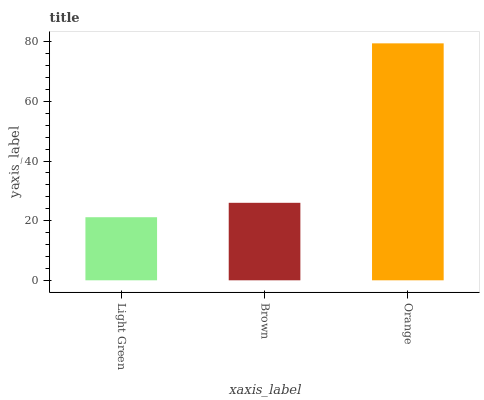Is Light Green the minimum?
Answer yes or no. Yes. Is Orange the maximum?
Answer yes or no. Yes. Is Brown the minimum?
Answer yes or no. No. Is Brown the maximum?
Answer yes or no. No. Is Brown greater than Light Green?
Answer yes or no. Yes. Is Light Green less than Brown?
Answer yes or no. Yes. Is Light Green greater than Brown?
Answer yes or no. No. Is Brown less than Light Green?
Answer yes or no. No. Is Brown the high median?
Answer yes or no. Yes. Is Brown the low median?
Answer yes or no. Yes. Is Light Green the high median?
Answer yes or no. No. Is Light Green the low median?
Answer yes or no. No. 